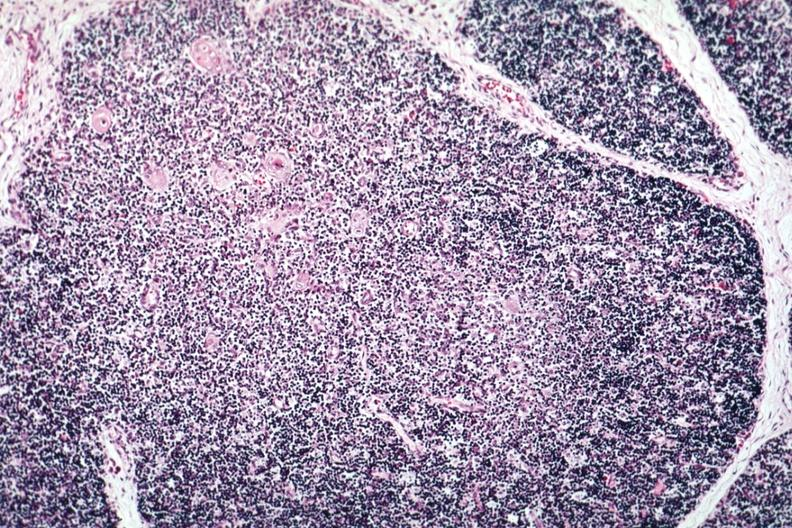what is present?
Answer the question using a single word or phrase. Hematologic 